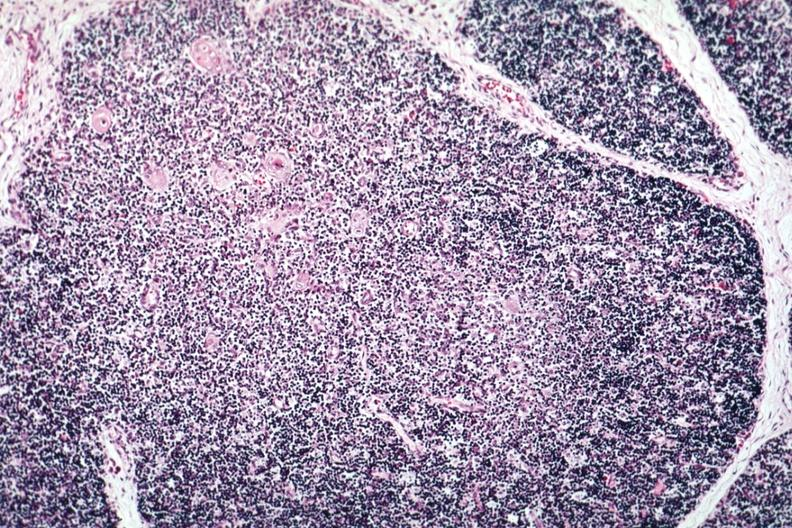what is present?
Answer the question using a single word or phrase. Hematologic 